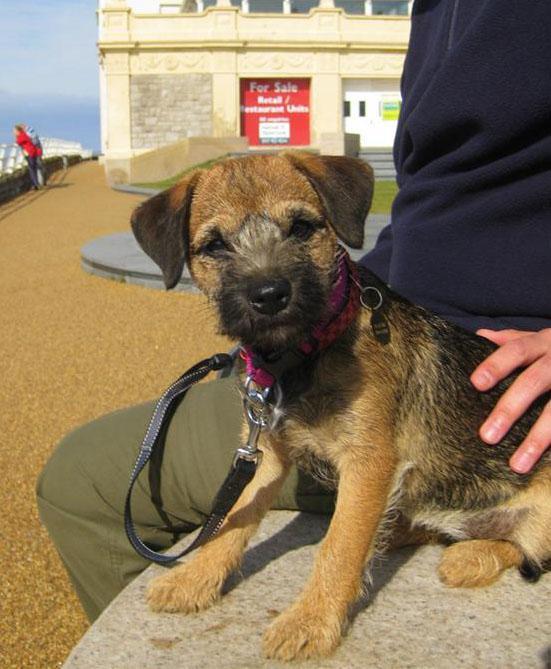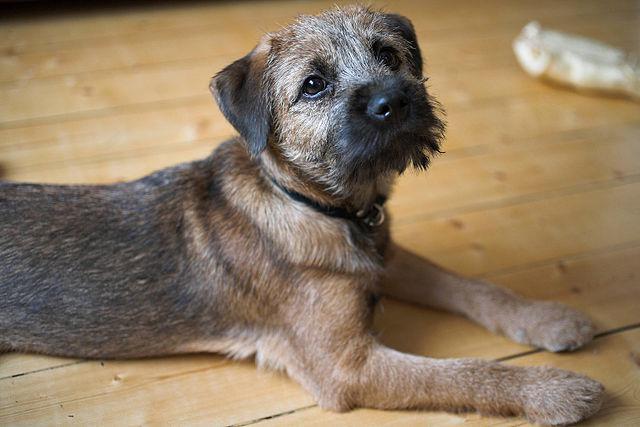The first image is the image on the left, the second image is the image on the right. Given the left and right images, does the statement "The dog in one of the images is being held in a person's hand." hold true? Answer yes or no. No. The first image is the image on the left, the second image is the image on the right. Given the left and right images, does the statement "One image shows a puppy held in a pair of hands, with its front paws draped over a hand." hold true? Answer yes or no. No. 